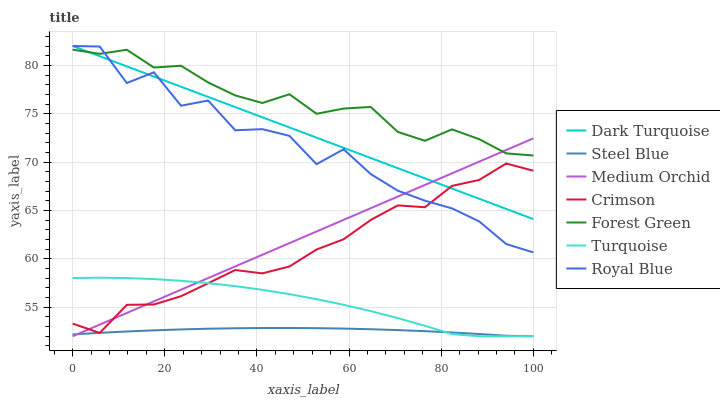Does Dark Turquoise have the minimum area under the curve?
Answer yes or no. No. Does Dark Turquoise have the maximum area under the curve?
Answer yes or no. No. Is Dark Turquoise the smoothest?
Answer yes or no. No. Is Dark Turquoise the roughest?
Answer yes or no. No. Does Dark Turquoise have the lowest value?
Answer yes or no. No. Does Medium Orchid have the highest value?
Answer yes or no. No. Is Turquoise less than Dark Turquoise?
Answer yes or no. Yes. Is Royal Blue greater than Steel Blue?
Answer yes or no. Yes. Does Turquoise intersect Dark Turquoise?
Answer yes or no. No. 